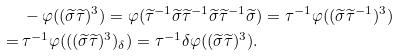<formula> <loc_0><loc_0><loc_500><loc_500>& - \varphi ( ( \widetilde { \sigma } \widetilde { \tau } ) ^ { 3 } ) = \varphi ( \widetilde { \tau } ^ { - 1 } \widetilde { \sigma } \widetilde { \tau } ^ { - 1 } \widetilde { \sigma } \widetilde { \tau } ^ { - 1 } \widetilde { \sigma } ) = \tau ^ { - 1 } \varphi ( ( \widetilde { \sigma } \widetilde { \tau } ^ { - 1 } ) ^ { 3 } ) \\ = \, & \tau ^ { - 1 } \varphi ( ( ( \widetilde { \sigma } \widetilde { \tau } ) ^ { 3 } ) _ { \delta } ) = \tau ^ { - 1 } \delta \varphi ( ( \widetilde { \sigma } \widetilde { \tau } ) ^ { 3 } ) .</formula> 